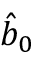Convert formula to latex. <formula><loc_0><loc_0><loc_500><loc_500>{ \hat { b } } _ { 0 }</formula> 